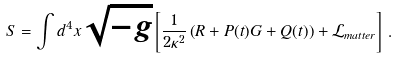Convert formula to latex. <formula><loc_0><loc_0><loc_500><loc_500>S = \int d ^ { 4 } x \sqrt { - g } \left [ \frac { 1 } { 2 \kappa ^ { 2 } } \left ( R + P ( t ) G + Q ( t ) \right ) + { \mathcal { L } } _ { m a t t e r } \right ] \, .</formula> 